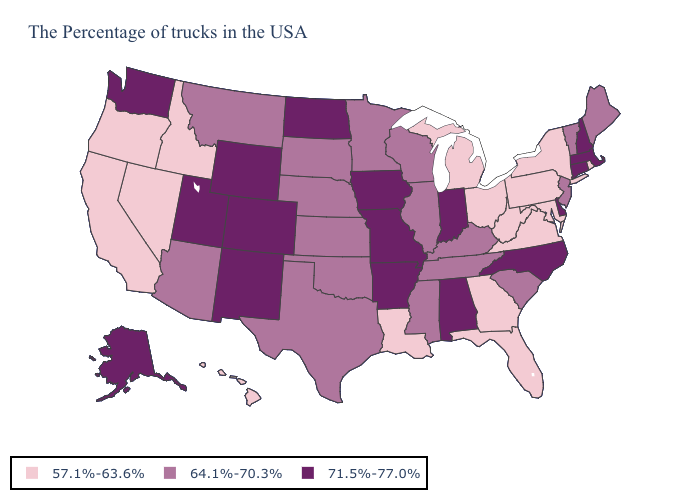Among the states that border New Mexico , which have the lowest value?
Give a very brief answer. Oklahoma, Texas, Arizona. Among the states that border New York , which have the highest value?
Quick response, please. Massachusetts, Connecticut. Which states have the lowest value in the USA?
Concise answer only. Rhode Island, New York, Maryland, Pennsylvania, Virginia, West Virginia, Ohio, Florida, Georgia, Michigan, Louisiana, Idaho, Nevada, California, Oregon, Hawaii. Name the states that have a value in the range 71.5%-77.0%?
Give a very brief answer. Massachusetts, New Hampshire, Connecticut, Delaware, North Carolina, Indiana, Alabama, Missouri, Arkansas, Iowa, North Dakota, Wyoming, Colorado, New Mexico, Utah, Washington, Alaska. What is the value of Texas?
Keep it brief. 64.1%-70.3%. What is the lowest value in the West?
Give a very brief answer. 57.1%-63.6%. Does Michigan have the lowest value in the USA?
Write a very short answer. Yes. Does Illinois have the highest value in the USA?
Give a very brief answer. No. Name the states that have a value in the range 71.5%-77.0%?
Be succinct. Massachusetts, New Hampshire, Connecticut, Delaware, North Carolina, Indiana, Alabama, Missouri, Arkansas, Iowa, North Dakota, Wyoming, Colorado, New Mexico, Utah, Washington, Alaska. What is the value of Idaho?
Give a very brief answer. 57.1%-63.6%. What is the highest value in the South ?
Be succinct. 71.5%-77.0%. Does the map have missing data?
Give a very brief answer. No. What is the highest value in the USA?
Short answer required. 71.5%-77.0%. 